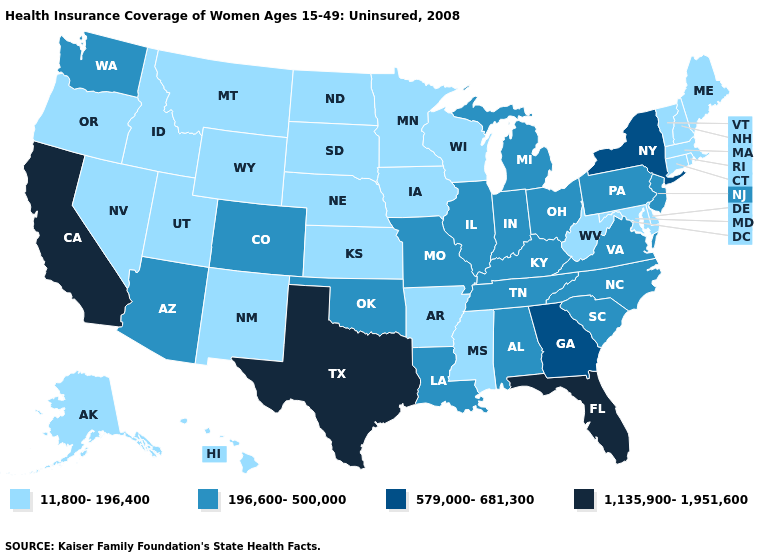Does Utah have the lowest value in the USA?
Answer briefly. Yes. What is the value of Arkansas?
Give a very brief answer. 11,800-196,400. What is the value of Delaware?
Concise answer only. 11,800-196,400. Does Georgia have the lowest value in the South?
Answer briefly. No. Does Michigan have a lower value than Florida?
Be succinct. Yes. What is the value of Alaska?
Write a very short answer. 11,800-196,400. Which states have the lowest value in the Northeast?
Concise answer only. Connecticut, Maine, Massachusetts, New Hampshire, Rhode Island, Vermont. Which states have the highest value in the USA?
Write a very short answer. California, Florida, Texas. What is the highest value in states that border Texas?
Give a very brief answer. 196,600-500,000. What is the value of Iowa?
Quick response, please. 11,800-196,400. What is the value of Washington?
Short answer required. 196,600-500,000. How many symbols are there in the legend?
Keep it brief. 4. Is the legend a continuous bar?
Be succinct. No. Name the states that have a value in the range 196,600-500,000?
Short answer required. Alabama, Arizona, Colorado, Illinois, Indiana, Kentucky, Louisiana, Michigan, Missouri, New Jersey, North Carolina, Ohio, Oklahoma, Pennsylvania, South Carolina, Tennessee, Virginia, Washington. What is the lowest value in states that border Michigan?
Answer briefly. 11,800-196,400. 